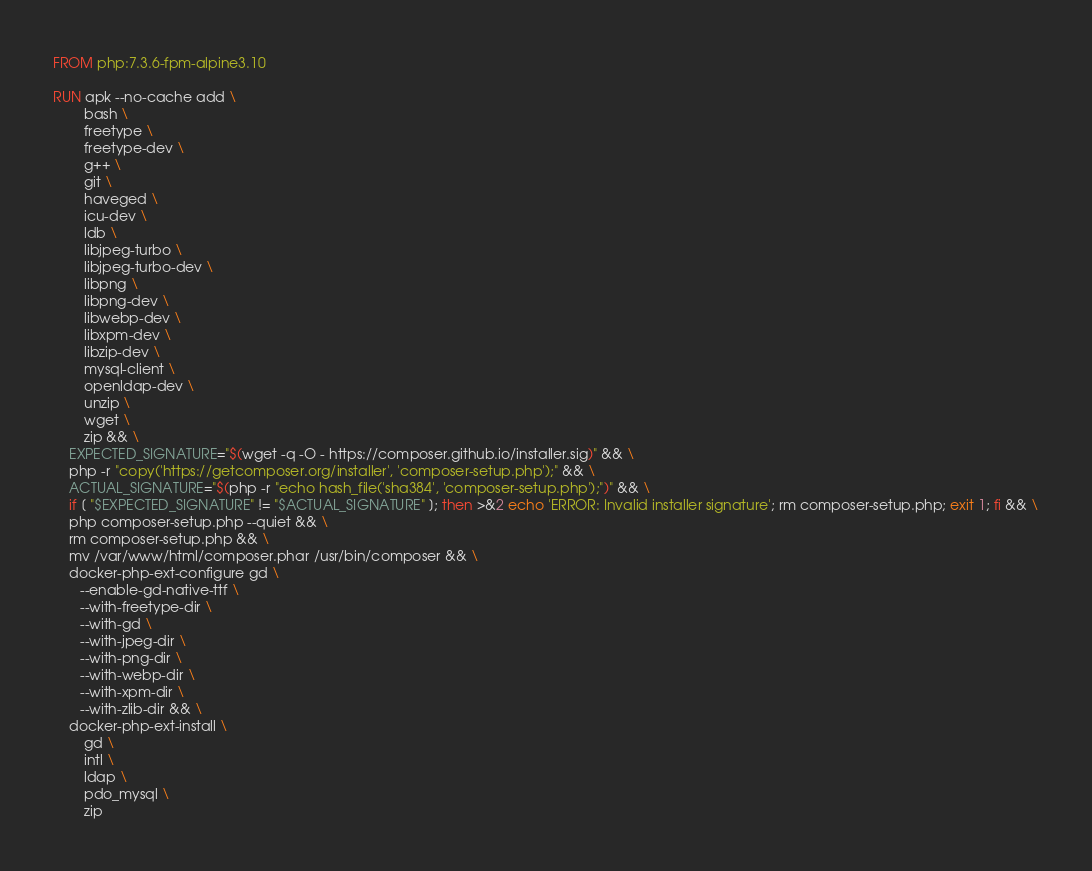<code> <loc_0><loc_0><loc_500><loc_500><_Dockerfile_>FROM php:7.3.6-fpm-alpine3.10

RUN apk --no-cache add \
        bash \
        freetype \
        freetype-dev \
        g++ \
        git \
        haveged \
        icu-dev \
        ldb \
        libjpeg-turbo \
        libjpeg-turbo-dev \
        libpng \
        libpng-dev \
        libwebp-dev \
        libxpm-dev \
        libzip-dev \
        mysql-client \
        openldap-dev \
        unzip \
        wget \
        zip && \
    EXPECTED_SIGNATURE="$(wget -q -O - https://composer.github.io/installer.sig)" && \
    php -r "copy('https://getcomposer.org/installer', 'composer-setup.php');" && \
    ACTUAL_SIGNATURE="$(php -r "echo hash_file('sha384', 'composer-setup.php');")" && \
    if [ "$EXPECTED_SIGNATURE" != "$ACTUAL_SIGNATURE" ]; then >&2 echo 'ERROR: Invalid installer signature'; rm composer-setup.php; exit 1; fi && \
    php composer-setup.php --quiet && \
    rm composer-setup.php && \
    mv /var/www/html/composer.phar /usr/bin/composer && \
    docker-php-ext-configure gd \
       --enable-gd-native-ttf \
       --with-freetype-dir \
       --with-gd \
       --with-jpeg-dir \
       --with-png-dir \
       --with-webp-dir \
       --with-xpm-dir \
       --with-zlib-dir && \
    docker-php-ext-install \
        gd \
        intl \
        ldap \
        pdo_mysql \
        zip
</code> 